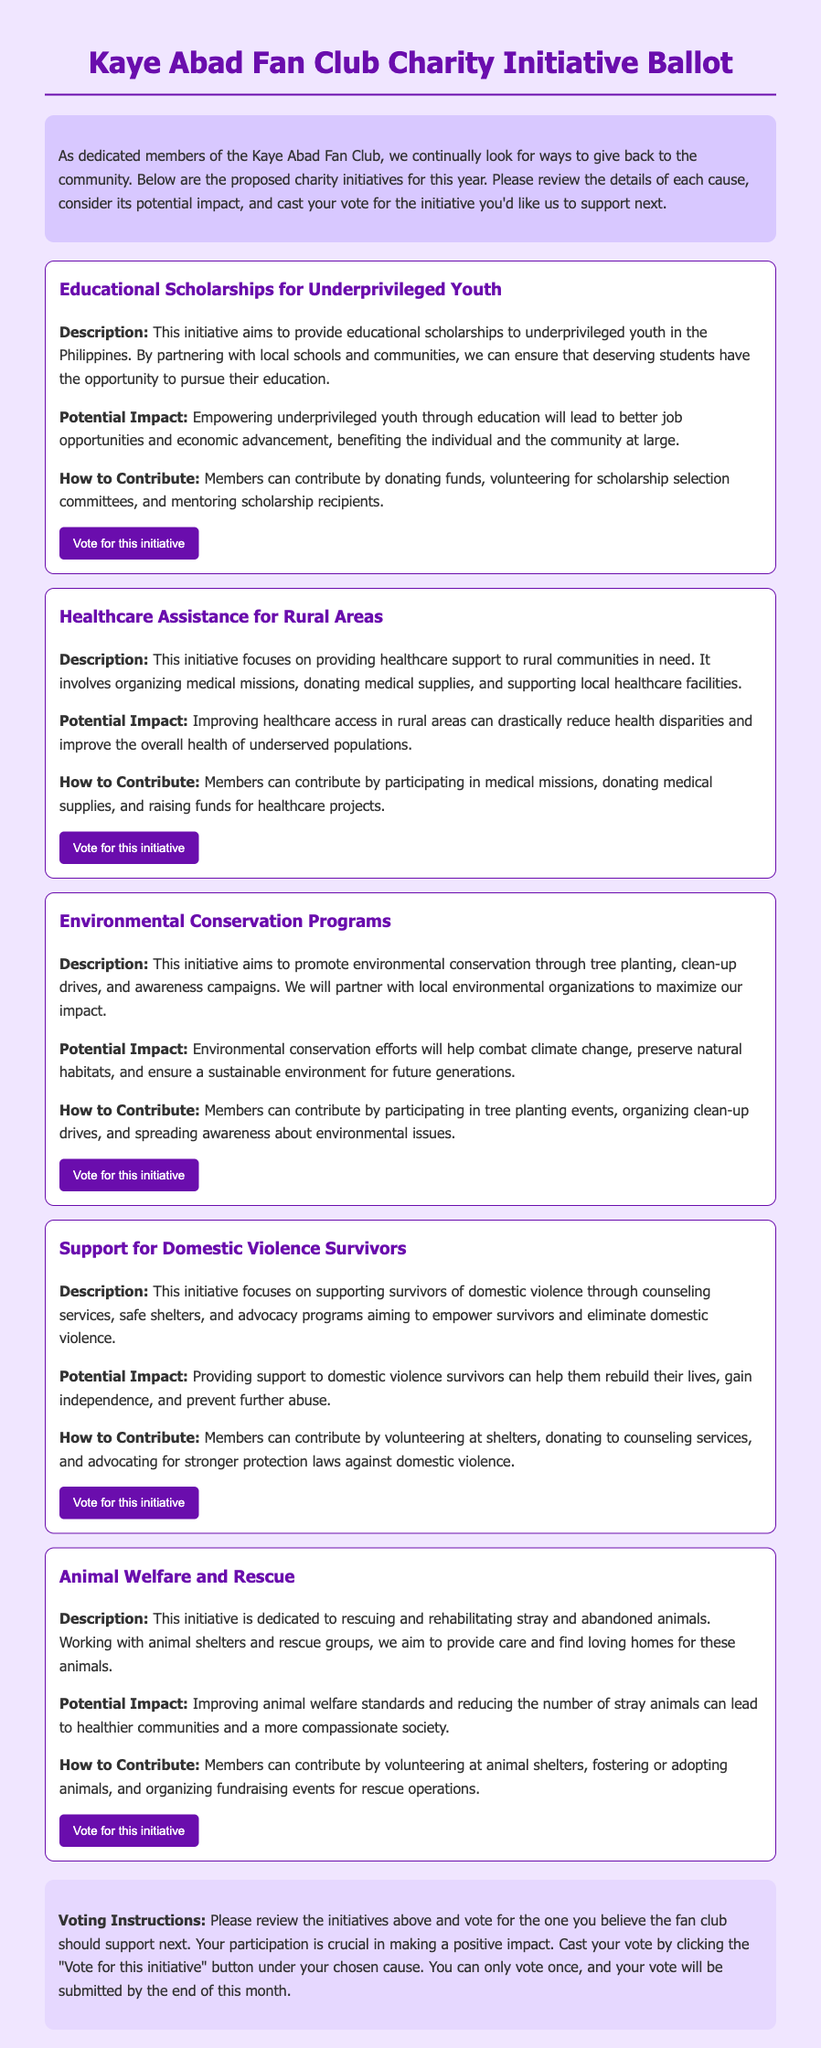What is the title of the ballot? The title is noted at the top of the document and provides the primary focus of the content.
Answer: Kaye Abad Fan Club Charity Initiative Ballot How many charity initiatives are proposed? The number of initiatives is indicated by the sections detailing each specific cause, counted for clarity.
Answer: Five What is the description of the initiative focusing on youth? The initiative describing support for youth specifically outlines its goals and goals related to education.
Answer: Educational Scholarships for Underprivileged Youth What potential impact is mentioned for environmental conservation? The potential impacts are summarized within the descriptions of each initiative, specifically regarding environmental issues.
Answer: Combat climate change What contribution is suggested for the healthcare initiative? The document outlines multiple ways members can contribute to various initiatives, including specific activities for healthcare.
Answer: Participating in medical missions How does the document instruct members to cast their vote? The voting method and the frequency are precisely defined in the instructions section at the end of the document.
Answer: Click the "Vote for this initiative" button What is a potential impact mentioned for supporting domestic violence survivors? Each initiative describes its potential impact on the community and individuals, with specific focus on survivors in this instance.
Answer: Help them rebuild their lives What volunteer action is suggested for animal welfare? The document lists various ways for members to engage and support charitable efforts, particularly for animals.
Answer: Volunteering at animal shelters What color is used prominently in the initiative design? The visual elements of the document indicate the primary color employed throughout various headings and buttons.
Answer: Purple 